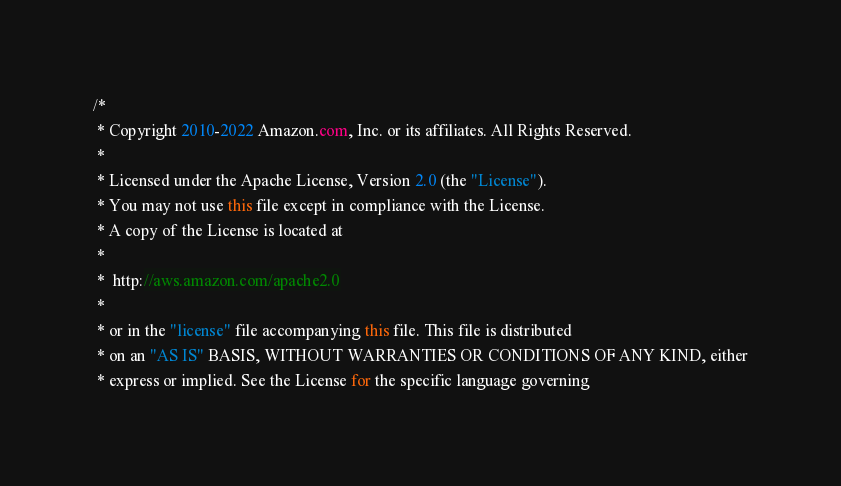Convert code to text. <code><loc_0><loc_0><loc_500><loc_500><_Java_>/*
 * Copyright 2010-2022 Amazon.com, Inc. or its affiliates. All Rights Reserved.
 *
 * Licensed under the Apache License, Version 2.0 (the "License").
 * You may not use this file except in compliance with the License.
 * A copy of the License is located at
 *
 *  http://aws.amazon.com/apache2.0
 *
 * or in the "license" file accompanying this file. This file is distributed
 * on an "AS IS" BASIS, WITHOUT WARRANTIES OR CONDITIONS OF ANY KIND, either
 * express or implied. See the License for the specific language governing</code> 